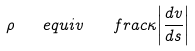<formula> <loc_0><loc_0><loc_500><loc_500>\rho \quad e q u i v \quad f r a c { \kappa } { \left | \frac { d v } { d s } \right | }</formula> 